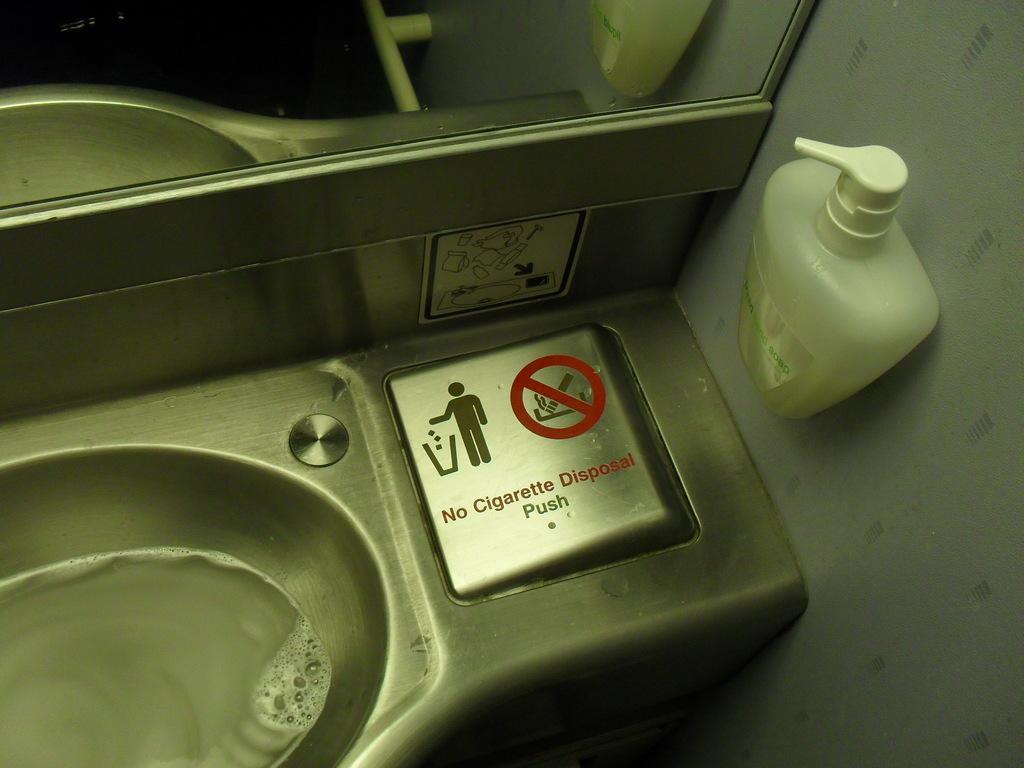In one or two sentences, can you explain what this image depicts? This is a sink and above it we can see a mirror beside to the mirror there is hand wash bottle. 